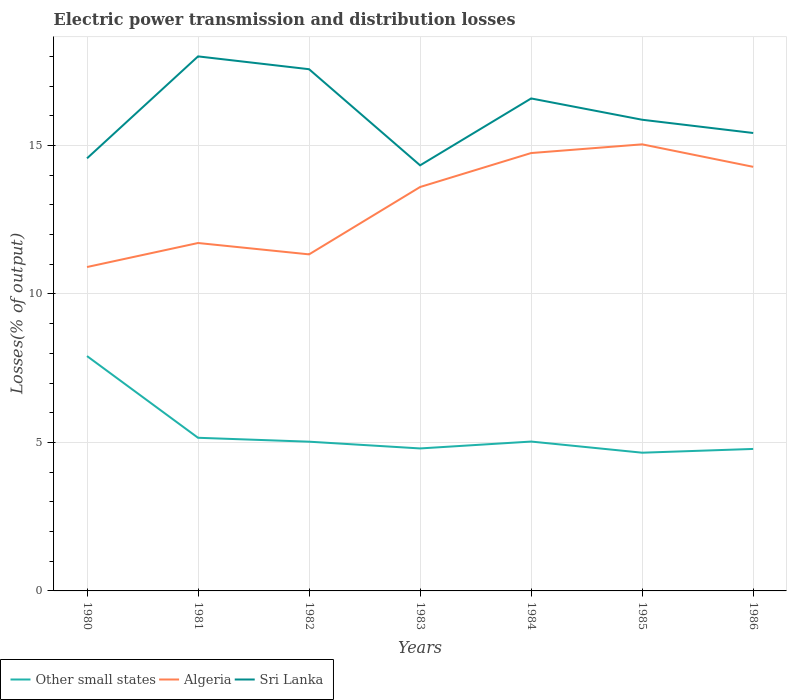How many different coloured lines are there?
Your answer should be compact. 3. Is the number of lines equal to the number of legend labels?
Your answer should be very brief. Yes. Across all years, what is the maximum electric power transmission and distribution losses in Other small states?
Ensure brevity in your answer.  4.66. In which year was the electric power transmission and distribution losses in Algeria maximum?
Keep it short and to the point. 1980. What is the total electric power transmission and distribution losses in Other small states in the graph?
Provide a short and direct response. 0.24. What is the difference between the highest and the second highest electric power transmission and distribution losses in Algeria?
Offer a terse response. 4.13. What is the difference between the highest and the lowest electric power transmission and distribution losses in Algeria?
Keep it short and to the point. 4. Is the electric power transmission and distribution losses in Sri Lanka strictly greater than the electric power transmission and distribution losses in Other small states over the years?
Provide a short and direct response. No. How many lines are there?
Give a very brief answer. 3. How many years are there in the graph?
Your response must be concise. 7. Are the values on the major ticks of Y-axis written in scientific E-notation?
Your answer should be compact. No. Does the graph contain any zero values?
Keep it short and to the point. No. Does the graph contain grids?
Ensure brevity in your answer.  Yes. How many legend labels are there?
Your answer should be very brief. 3. What is the title of the graph?
Your answer should be compact. Electric power transmission and distribution losses. Does "Marshall Islands" appear as one of the legend labels in the graph?
Your response must be concise. No. What is the label or title of the Y-axis?
Provide a succinct answer. Losses(% of output). What is the Losses(% of output) of Other small states in 1980?
Offer a very short reply. 7.91. What is the Losses(% of output) in Algeria in 1980?
Ensure brevity in your answer.  10.91. What is the Losses(% of output) in Sri Lanka in 1980?
Provide a succinct answer. 14.57. What is the Losses(% of output) of Other small states in 1981?
Keep it short and to the point. 5.16. What is the Losses(% of output) of Algeria in 1981?
Your answer should be very brief. 11.72. What is the Losses(% of output) in Sri Lanka in 1981?
Ensure brevity in your answer.  18. What is the Losses(% of output) of Other small states in 1982?
Ensure brevity in your answer.  5.03. What is the Losses(% of output) of Algeria in 1982?
Offer a very short reply. 11.33. What is the Losses(% of output) in Sri Lanka in 1982?
Provide a succinct answer. 17.57. What is the Losses(% of output) in Other small states in 1983?
Make the answer very short. 4.8. What is the Losses(% of output) in Algeria in 1983?
Offer a very short reply. 13.6. What is the Losses(% of output) in Sri Lanka in 1983?
Your response must be concise. 14.33. What is the Losses(% of output) in Other small states in 1984?
Keep it short and to the point. 5.03. What is the Losses(% of output) of Algeria in 1984?
Provide a succinct answer. 14.75. What is the Losses(% of output) of Sri Lanka in 1984?
Your response must be concise. 16.59. What is the Losses(% of output) of Other small states in 1985?
Make the answer very short. 4.66. What is the Losses(% of output) in Algeria in 1985?
Your response must be concise. 15.04. What is the Losses(% of output) of Sri Lanka in 1985?
Give a very brief answer. 15.87. What is the Losses(% of output) of Other small states in 1986?
Provide a short and direct response. 4.78. What is the Losses(% of output) of Algeria in 1986?
Keep it short and to the point. 14.28. What is the Losses(% of output) of Sri Lanka in 1986?
Give a very brief answer. 15.42. Across all years, what is the maximum Losses(% of output) of Other small states?
Offer a very short reply. 7.91. Across all years, what is the maximum Losses(% of output) of Algeria?
Offer a very short reply. 15.04. Across all years, what is the maximum Losses(% of output) of Sri Lanka?
Make the answer very short. 18. Across all years, what is the minimum Losses(% of output) in Other small states?
Offer a terse response. 4.66. Across all years, what is the minimum Losses(% of output) of Algeria?
Offer a very short reply. 10.91. Across all years, what is the minimum Losses(% of output) of Sri Lanka?
Ensure brevity in your answer.  14.33. What is the total Losses(% of output) in Other small states in the graph?
Keep it short and to the point. 37.36. What is the total Losses(% of output) of Algeria in the graph?
Your answer should be compact. 91.63. What is the total Losses(% of output) in Sri Lanka in the graph?
Your response must be concise. 112.35. What is the difference between the Losses(% of output) in Other small states in 1980 and that in 1981?
Keep it short and to the point. 2.75. What is the difference between the Losses(% of output) in Algeria in 1980 and that in 1981?
Provide a short and direct response. -0.81. What is the difference between the Losses(% of output) in Sri Lanka in 1980 and that in 1981?
Your answer should be very brief. -3.43. What is the difference between the Losses(% of output) in Other small states in 1980 and that in 1982?
Offer a very short reply. 2.88. What is the difference between the Losses(% of output) in Algeria in 1980 and that in 1982?
Your answer should be compact. -0.43. What is the difference between the Losses(% of output) in Sri Lanka in 1980 and that in 1982?
Provide a succinct answer. -3. What is the difference between the Losses(% of output) in Other small states in 1980 and that in 1983?
Keep it short and to the point. 3.11. What is the difference between the Losses(% of output) in Algeria in 1980 and that in 1983?
Ensure brevity in your answer.  -2.7. What is the difference between the Losses(% of output) of Sri Lanka in 1980 and that in 1983?
Ensure brevity in your answer.  0.24. What is the difference between the Losses(% of output) of Other small states in 1980 and that in 1984?
Your response must be concise. 2.88. What is the difference between the Losses(% of output) of Algeria in 1980 and that in 1984?
Your response must be concise. -3.84. What is the difference between the Losses(% of output) of Sri Lanka in 1980 and that in 1984?
Your answer should be very brief. -2.02. What is the difference between the Losses(% of output) of Other small states in 1980 and that in 1985?
Provide a short and direct response. 3.25. What is the difference between the Losses(% of output) of Algeria in 1980 and that in 1985?
Keep it short and to the point. -4.13. What is the difference between the Losses(% of output) of Sri Lanka in 1980 and that in 1985?
Your answer should be very brief. -1.3. What is the difference between the Losses(% of output) of Other small states in 1980 and that in 1986?
Offer a very short reply. 3.13. What is the difference between the Losses(% of output) in Algeria in 1980 and that in 1986?
Make the answer very short. -3.37. What is the difference between the Losses(% of output) of Sri Lanka in 1980 and that in 1986?
Ensure brevity in your answer.  -0.85. What is the difference between the Losses(% of output) of Other small states in 1981 and that in 1982?
Your response must be concise. 0.13. What is the difference between the Losses(% of output) in Algeria in 1981 and that in 1982?
Ensure brevity in your answer.  0.38. What is the difference between the Losses(% of output) of Sri Lanka in 1981 and that in 1982?
Your answer should be compact. 0.43. What is the difference between the Losses(% of output) of Other small states in 1981 and that in 1983?
Provide a short and direct response. 0.36. What is the difference between the Losses(% of output) of Algeria in 1981 and that in 1983?
Your answer should be very brief. -1.89. What is the difference between the Losses(% of output) of Sri Lanka in 1981 and that in 1983?
Your answer should be very brief. 3.67. What is the difference between the Losses(% of output) of Other small states in 1981 and that in 1984?
Offer a very short reply. 0.13. What is the difference between the Losses(% of output) of Algeria in 1981 and that in 1984?
Your response must be concise. -3.03. What is the difference between the Losses(% of output) of Sri Lanka in 1981 and that in 1984?
Offer a very short reply. 1.42. What is the difference between the Losses(% of output) in Other small states in 1981 and that in 1985?
Your response must be concise. 0.5. What is the difference between the Losses(% of output) of Algeria in 1981 and that in 1985?
Offer a terse response. -3.32. What is the difference between the Losses(% of output) of Sri Lanka in 1981 and that in 1985?
Provide a short and direct response. 2.13. What is the difference between the Losses(% of output) of Other small states in 1981 and that in 1986?
Your response must be concise. 0.38. What is the difference between the Losses(% of output) of Algeria in 1981 and that in 1986?
Provide a short and direct response. -2.57. What is the difference between the Losses(% of output) in Sri Lanka in 1981 and that in 1986?
Your response must be concise. 2.58. What is the difference between the Losses(% of output) of Other small states in 1982 and that in 1983?
Your answer should be compact. 0.23. What is the difference between the Losses(% of output) of Algeria in 1982 and that in 1983?
Your answer should be very brief. -2.27. What is the difference between the Losses(% of output) of Sri Lanka in 1982 and that in 1983?
Keep it short and to the point. 3.24. What is the difference between the Losses(% of output) of Other small states in 1982 and that in 1984?
Your answer should be very brief. -0. What is the difference between the Losses(% of output) in Algeria in 1982 and that in 1984?
Provide a short and direct response. -3.41. What is the difference between the Losses(% of output) in Sri Lanka in 1982 and that in 1984?
Your answer should be compact. 0.98. What is the difference between the Losses(% of output) in Other small states in 1982 and that in 1985?
Your answer should be compact. 0.37. What is the difference between the Losses(% of output) of Algeria in 1982 and that in 1985?
Offer a very short reply. -3.71. What is the difference between the Losses(% of output) of Sri Lanka in 1982 and that in 1985?
Your answer should be compact. 1.7. What is the difference between the Losses(% of output) in Other small states in 1982 and that in 1986?
Your answer should be very brief. 0.24. What is the difference between the Losses(% of output) in Algeria in 1982 and that in 1986?
Make the answer very short. -2.95. What is the difference between the Losses(% of output) of Sri Lanka in 1982 and that in 1986?
Provide a succinct answer. 2.15. What is the difference between the Losses(% of output) in Other small states in 1983 and that in 1984?
Offer a very short reply. -0.23. What is the difference between the Losses(% of output) in Algeria in 1983 and that in 1984?
Ensure brevity in your answer.  -1.14. What is the difference between the Losses(% of output) of Sri Lanka in 1983 and that in 1984?
Ensure brevity in your answer.  -2.25. What is the difference between the Losses(% of output) in Other small states in 1983 and that in 1985?
Give a very brief answer. 0.14. What is the difference between the Losses(% of output) in Algeria in 1983 and that in 1985?
Provide a succinct answer. -1.44. What is the difference between the Losses(% of output) of Sri Lanka in 1983 and that in 1985?
Make the answer very short. -1.54. What is the difference between the Losses(% of output) of Other small states in 1983 and that in 1986?
Give a very brief answer. 0.02. What is the difference between the Losses(% of output) in Algeria in 1983 and that in 1986?
Keep it short and to the point. -0.68. What is the difference between the Losses(% of output) in Sri Lanka in 1983 and that in 1986?
Offer a terse response. -1.09. What is the difference between the Losses(% of output) in Other small states in 1984 and that in 1985?
Keep it short and to the point. 0.38. What is the difference between the Losses(% of output) in Algeria in 1984 and that in 1985?
Your response must be concise. -0.29. What is the difference between the Losses(% of output) in Sri Lanka in 1984 and that in 1985?
Give a very brief answer. 0.72. What is the difference between the Losses(% of output) of Other small states in 1984 and that in 1986?
Your answer should be compact. 0.25. What is the difference between the Losses(% of output) of Algeria in 1984 and that in 1986?
Offer a terse response. 0.46. What is the difference between the Losses(% of output) in Sri Lanka in 1984 and that in 1986?
Provide a short and direct response. 1.16. What is the difference between the Losses(% of output) of Other small states in 1985 and that in 1986?
Make the answer very short. -0.13. What is the difference between the Losses(% of output) of Algeria in 1985 and that in 1986?
Your answer should be very brief. 0.76. What is the difference between the Losses(% of output) of Sri Lanka in 1985 and that in 1986?
Keep it short and to the point. 0.45. What is the difference between the Losses(% of output) in Other small states in 1980 and the Losses(% of output) in Algeria in 1981?
Offer a very short reply. -3.81. What is the difference between the Losses(% of output) in Other small states in 1980 and the Losses(% of output) in Sri Lanka in 1981?
Ensure brevity in your answer.  -10.09. What is the difference between the Losses(% of output) in Algeria in 1980 and the Losses(% of output) in Sri Lanka in 1981?
Your answer should be compact. -7.09. What is the difference between the Losses(% of output) of Other small states in 1980 and the Losses(% of output) of Algeria in 1982?
Ensure brevity in your answer.  -3.42. What is the difference between the Losses(% of output) in Other small states in 1980 and the Losses(% of output) in Sri Lanka in 1982?
Offer a very short reply. -9.66. What is the difference between the Losses(% of output) in Algeria in 1980 and the Losses(% of output) in Sri Lanka in 1982?
Your answer should be very brief. -6.66. What is the difference between the Losses(% of output) in Other small states in 1980 and the Losses(% of output) in Algeria in 1983?
Your answer should be very brief. -5.69. What is the difference between the Losses(% of output) of Other small states in 1980 and the Losses(% of output) of Sri Lanka in 1983?
Keep it short and to the point. -6.42. What is the difference between the Losses(% of output) in Algeria in 1980 and the Losses(% of output) in Sri Lanka in 1983?
Your response must be concise. -3.42. What is the difference between the Losses(% of output) of Other small states in 1980 and the Losses(% of output) of Algeria in 1984?
Your answer should be compact. -6.84. What is the difference between the Losses(% of output) of Other small states in 1980 and the Losses(% of output) of Sri Lanka in 1984?
Offer a terse response. -8.68. What is the difference between the Losses(% of output) of Algeria in 1980 and the Losses(% of output) of Sri Lanka in 1984?
Ensure brevity in your answer.  -5.68. What is the difference between the Losses(% of output) of Other small states in 1980 and the Losses(% of output) of Algeria in 1985?
Keep it short and to the point. -7.13. What is the difference between the Losses(% of output) of Other small states in 1980 and the Losses(% of output) of Sri Lanka in 1985?
Offer a very short reply. -7.96. What is the difference between the Losses(% of output) of Algeria in 1980 and the Losses(% of output) of Sri Lanka in 1985?
Offer a very short reply. -4.96. What is the difference between the Losses(% of output) in Other small states in 1980 and the Losses(% of output) in Algeria in 1986?
Your answer should be very brief. -6.37. What is the difference between the Losses(% of output) in Other small states in 1980 and the Losses(% of output) in Sri Lanka in 1986?
Your answer should be compact. -7.51. What is the difference between the Losses(% of output) in Algeria in 1980 and the Losses(% of output) in Sri Lanka in 1986?
Give a very brief answer. -4.51. What is the difference between the Losses(% of output) of Other small states in 1981 and the Losses(% of output) of Algeria in 1982?
Ensure brevity in your answer.  -6.18. What is the difference between the Losses(% of output) in Other small states in 1981 and the Losses(% of output) in Sri Lanka in 1982?
Give a very brief answer. -12.41. What is the difference between the Losses(% of output) of Algeria in 1981 and the Losses(% of output) of Sri Lanka in 1982?
Keep it short and to the point. -5.85. What is the difference between the Losses(% of output) of Other small states in 1981 and the Losses(% of output) of Algeria in 1983?
Offer a terse response. -8.45. What is the difference between the Losses(% of output) of Other small states in 1981 and the Losses(% of output) of Sri Lanka in 1983?
Offer a very short reply. -9.18. What is the difference between the Losses(% of output) of Algeria in 1981 and the Losses(% of output) of Sri Lanka in 1983?
Provide a short and direct response. -2.62. What is the difference between the Losses(% of output) of Other small states in 1981 and the Losses(% of output) of Algeria in 1984?
Your answer should be compact. -9.59. What is the difference between the Losses(% of output) of Other small states in 1981 and the Losses(% of output) of Sri Lanka in 1984?
Your answer should be compact. -11.43. What is the difference between the Losses(% of output) of Algeria in 1981 and the Losses(% of output) of Sri Lanka in 1984?
Offer a terse response. -4.87. What is the difference between the Losses(% of output) of Other small states in 1981 and the Losses(% of output) of Algeria in 1985?
Ensure brevity in your answer.  -9.88. What is the difference between the Losses(% of output) of Other small states in 1981 and the Losses(% of output) of Sri Lanka in 1985?
Provide a short and direct response. -10.71. What is the difference between the Losses(% of output) in Algeria in 1981 and the Losses(% of output) in Sri Lanka in 1985?
Your answer should be compact. -4.15. What is the difference between the Losses(% of output) of Other small states in 1981 and the Losses(% of output) of Algeria in 1986?
Offer a terse response. -9.12. What is the difference between the Losses(% of output) of Other small states in 1981 and the Losses(% of output) of Sri Lanka in 1986?
Offer a terse response. -10.26. What is the difference between the Losses(% of output) of Algeria in 1981 and the Losses(% of output) of Sri Lanka in 1986?
Offer a terse response. -3.71. What is the difference between the Losses(% of output) in Other small states in 1982 and the Losses(% of output) in Algeria in 1983?
Make the answer very short. -8.58. What is the difference between the Losses(% of output) in Other small states in 1982 and the Losses(% of output) in Sri Lanka in 1983?
Offer a terse response. -9.31. What is the difference between the Losses(% of output) in Algeria in 1982 and the Losses(% of output) in Sri Lanka in 1983?
Your response must be concise. -3. What is the difference between the Losses(% of output) of Other small states in 1982 and the Losses(% of output) of Algeria in 1984?
Your answer should be very brief. -9.72. What is the difference between the Losses(% of output) of Other small states in 1982 and the Losses(% of output) of Sri Lanka in 1984?
Provide a short and direct response. -11.56. What is the difference between the Losses(% of output) in Algeria in 1982 and the Losses(% of output) in Sri Lanka in 1984?
Offer a very short reply. -5.25. What is the difference between the Losses(% of output) in Other small states in 1982 and the Losses(% of output) in Algeria in 1985?
Offer a terse response. -10.01. What is the difference between the Losses(% of output) in Other small states in 1982 and the Losses(% of output) in Sri Lanka in 1985?
Provide a short and direct response. -10.84. What is the difference between the Losses(% of output) of Algeria in 1982 and the Losses(% of output) of Sri Lanka in 1985?
Offer a terse response. -4.53. What is the difference between the Losses(% of output) of Other small states in 1982 and the Losses(% of output) of Algeria in 1986?
Give a very brief answer. -9.26. What is the difference between the Losses(% of output) of Other small states in 1982 and the Losses(% of output) of Sri Lanka in 1986?
Ensure brevity in your answer.  -10.4. What is the difference between the Losses(% of output) of Algeria in 1982 and the Losses(% of output) of Sri Lanka in 1986?
Offer a very short reply. -4.09. What is the difference between the Losses(% of output) of Other small states in 1983 and the Losses(% of output) of Algeria in 1984?
Offer a very short reply. -9.95. What is the difference between the Losses(% of output) in Other small states in 1983 and the Losses(% of output) in Sri Lanka in 1984?
Provide a succinct answer. -11.79. What is the difference between the Losses(% of output) in Algeria in 1983 and the Losses(% of output) in Sri Lanka in 1984?
Offer a very short reply. -2.98. What is the difference between the Losses(% of output) of Other small states in 1983 and the Losses(% of output) of Algeria in 1985?
Your answer should be compact. -10.24. What is the difference between the Losses(% of output) of Other small states in 1983 and the Losses(% of output) of Sri Lanka in 1985?
Provide a succinct answer. -11.07. What is the difference between the Losses(% of output) in Algeria in 1983 and the Losses(% of output) in Sri Lanka in 1985?
Keep it short and to the point. -2.27. What is the difference between the Losses(% of output) in Other small states in 1983 and the Losses(% of output) in Algeria in 1986?
Your answer should be very brief. -9.48. What is the difference between the Losses(% of output) in Other small states in 1983 and the Losses(% of output) in Sri Lanka in 1986?
Make the answer very short. -10.62. What is the difference between the Losses(% of output) in Algeria in 1983 and the Losses(% of output) in Sri Lanka in 1986?
Give a very brief answer. -1.82. What is the difference between the Losses(% of output) of Other small states in 1984 and the Losses(% of output) of Algeria in 1985?
Provide a succinct answer. -10.01. What is the difference between the Losses(% of output) of Other small states in 1984 and the Losses(% of output) of Sri Lanka in 1985?
Ensure brevity in your answer.  -10.84. What is the difference between the Losses(% of output) of Algeria in 1984 and the Losses(% of output) of Sri Lanka in 1985?
Provide a succinct answer. -1.12. What is the difference between the Losses(% of output) in Other small states in 1984 and the Losses(% of output) in Algeria in 1986?
Make the answer very short. -9.25. What is the difference between the Losses(% of output) of Other small states in 1984 and the Losses(% of output) of Sri Lanka in 1986?
Provide a short and direct response. -10.39. What is the difference between the Losses(% of output) in Algeria in 1984 and the Losses(% of output) in Sri Lanka in 1986?
Make the answer very short. -0.68. What is the difference between the Losses(% of output) in Other small states in 1985 and the Losses(% of output) in Algeria in 1986?
Your answer should be compact. -9.63. What is the difference between the Losses(% of output) in Other small states in 1985 and the Losses(% of output) in Sri Lanka in 1986?
Provide a succinct answer. -10.77. What is the difference between the Losses(% of output) in Algeria in 1985 and the Losses(% of output) in Sri Lanka in 1986?
Your answer should be very brief. -0.38. What is the average Losses(% of output) in Other small states per year?
Give a very brief answer. 5.34. What is the average Losses(% of output) in Algeria per year?
Make the answer very short. 13.09. What is the average Losses(% of output) of Sri Lanka per year?
Your answer should be very brief. 16.05. In the year 1980, what is the difference between the Losses(% of output) of Other small states and Losses(% of output) of Algeria?
Your response must be concise. -3. In the year 1980, what is the difference between the Losses(% of output) in Other small states and Losses(% of output) in Sri Lanka?
Provide a short and direct response. -6.66. In the year 1980, what is the difference between the Losses(% of output) in Algeria and Losses(% of output) in Sri Lanka?
Give a very brief answer. -3.66. In the year 1981, what is the difference between the Losses(% of output) of Other small states and Losses(% of output) of Algeria?
Keep it short and to the point. -6.56. In the year 1981, what is the difference between the Losses(% of output) in Other small states and Losses(% of output) in Sri Lanka?
Keep it short and to the point. -12.84. In the year 1981, what is the difference between the Losses(% of output) of Algeria and Losses(% of output) of Sri Lanka?
Keep it short and to the point. -6.29. In the year 1982, what is the difference between the Losses(% of output) in Other small states and Losses(% of output) in Algeria?
Offer a very short reply. -6.31. In the year 1982, what is the difference between the Losses(% of output) in Other small states and Losses(% of output) in Sri Lanka?
Give a very brief answer. -12.54. In the year 1982, what is the difference between the Losses(% of output) in Algeria and Losses(% of output) in Sri Lanka?
Give a very brief answer. -6.24. In the year 1983, what is the difference between the Losses(% of output) in Other small states and Losses(% of output) in Algeria?
Offer a terse response. -8.8. In the year 1983, what is the difference between the Losses(% of output) in Other small states and Losses(% of output) in Sri Lanka?
Make the answer very short. -9.53. In the year 1983, what is the difference between the Losses(% of output) in Algeria and Losses(% of output) in Sri Lanka?
Make the answer very short. -0.73. In the year 1984, what is the difference between the Losses(% of output) of Other small states and Losses(% of output) of Algeria?
Your answer should be very brief. -9.72. In the year 1984, what is the difference between the Losses(% of output) of Other small states and Losses(% of output) of Sri Lanka?
Provide a short and direct response. -11.56. In the year 1984, what is the difference between the Losses(% of output) of Algeria and Losses(% of output) of Sri Lanka?
Your answer should be very brief. -1.84. In the year 1985, what is the difference between the Losses(% of output) of Other small states and Losses(% of output) of Algeria?
Ensure brevity in your answer.  -10.38. In the year 1985, what is the difference between the Losses(% of output) in Other small states and Losses(% of output) in Sri Lanka?
Offer a very short reply. -11.21. In the year 1985, what is the difference between the Losses(% of output) in Algeria and Losses(% of output) in Sri Lanka?
Offer a terse response. -0.83. In the year 1986, what is the difference between the Losses(% of output) in Other small states and Losses(% of output) in Algeria?
Your response must be concise. -9.5. In the year 1986, what is the difference between the Losses(% of output) of Other small states and Losses(% of output) of Sri Lanka?
Ensure brevity in your answer.  -10.64. In the year 1986, what is the difference between the Losses(% of output) of Algeria and Losses(% of output) of Sri Lanka?
Offer a very short reply. -1.14. What is the ratio of the Losses(% of output) of Other small states in 1980 to that in 1981?
Give a very brief answer. 1.53. What is the ratio of the Losses(% of output) of Sri Lanka in 1980 to that in 1981?
Provide a short and direct response. 0.81. What is the ratio of the Losses(% of output) of Other small states in 1980 to that in 1982?
Keep it short and to the point. 1.57. What is the ratio of the Losses(% of output) in Algeria in 1980 to that in 1982?
Provide a succinct answer. 0.96. What is the ratio of the Losses(% of output) of Sri Lanka in 1980 to that in 1982?
Your answer should be compact. 0.83. What is the ratio of the Losses(% of output) of Other small states in 1980 to that in 1983?
Your response must be concise. 1.65. What is the ratio of the Losses(% of output) of Algeria in 1980 to that in 1983?
Ensure brevity in your answer.  0.8. What is the ratio of the Losses(% of output) of Sri Lanka in 1980 to that in 1983?
Keep it short and to the point. 1.02. What is the ratio of the Losses(% of output) of Other small states in 1980 to that in 1984?
Keep it short and to the point. 1.57. What is the ratio of the Losses(% of output) in Algeria in 1980 to that in 1984?
Your answer should be very brief. 0.74. What is the ratio of the Losses(% of output) of Sri Lanka in 1980 to that in 1984?
Your response must be concise. 0.88. What is the ratio of the Losses(% of output) in Other small states in 1980 to that in 1985?
Make the answer very short. 1.7. What is the ratio of the Losses(% of output) in Algeria in 1980 to that in 1985?
Your answer should be very brief. 0.73. What is the ratio of the Losses(% of output) in Sri Lanka in 1980 to that in 1985?
Offer a terse response. 0.92. What is the ratio of the Losses(% of output) of Other small states in 1980 to that in 1986?
Keep it short and to the point. 1.65. What is the ratio of the Losses(% of output) of Algeria in 1980 to that in 1986?
Ensure brevity in your answer.  0.76. What is the ratio of the Losses(% of output) of Sri Lanka in 1980 to that in 1986?
Provide a succinct answer. 0.94. What is the ratio of the Losses(% of output) in Other small states in 1981 to that in 1982?
Offer a terse response. 1.03. What is the ratio of the Losses(% of output) of Algeria in 1981 to that in 1982?
Your answer should be very brief. 1.03. What is the ratio of the Losses(% of output) in Sri Lanka in 1981 to that in 1982?
Give a very brief answer. 1.02. What is the ratio of the Losses(% of output) in Other small states in 1981 to that in 1983?
Your response must be concise. 1.07. What is the ratio of the Losses(% of output) in Algeria in 1981 to that in 1983?
Provide a succinct answer. 0.86. What is the ratio of the Losses(% of output) of Sri Lanka in 1981 to that in 1983?
Your answer should be very brief. 1.26. What is the ratio of the Losses(% of output) of Other small states in 1981 to that in 1984?
Provide a succinct answer. 1.03. What is the ratio of the Losses(% of output) in Algeria in 1981 to that in 1984?
Provide a succinct answer. 0.79. What is the ratio of the Losses(% of output) in Sri Lanka in 1981 to that in 1984?
Make the answer very short. 1.09. What is the ratio of the Losses(% of output) of Other small states in 1981 to that in 1985?
Provide a short and direct response. 1.11. What is the ratio of the Losses(% of output) in Algeria in 1981 to that in 1985?
Offer a very short reply. 0.78. What is the ratio of the Losses(% of output) of Sri Lanka in 1981 to that in 1985?
Ensure brevity in your answer.  1.13. What is the ratio of the Losses(% of output) in Other small states in 1981 to that in 1986?
Provide a succinct answer. 1.08. What is the ratio of the Losses(% of output) in Algeria in 1981 to that in 1986?
Your answer should be very brief. 0.82. What is the ratio of the Losses(% of output) in Sri Lanka in 1981 to that in 1986?
Make the answer very short. 1.17. What is the ratio of the Losses(% of output) in Other small states in 1982 to that in 1983?
Keep it short and to the point. 1.05. What is the ratio of the Losses(% of output) in Algeria in 1982 to that in 1983?
Give a very brief answer. 0.83. What is the ratio of the Losses(% of output) of Sri Lanka in 1982 to that in 1983?
Your answer should be very brief. 1.23. What is the ratio of the Losses(% of output) in Other small states in 1982 to that in 1984?
Offer a very short reply. 1. What is the ratio of the Losses(% of output) in Algeria in 1982 to that in 1984?
Your answer should be very brief. 0.77. What is the ratio of the Losses(% of output) of Sri Lanka in 1982 to that in 1984?
Your answer should be compact. 1.06. What is the ratio of the Losses(% of output) of Other small states in 1982 to that in 1985?
Provide a short and direct response. 1.08. What is the ratio of the Losses(% of output) in Algeria in 1982 to that in 1985?
Provide a succinct answer. 0.75. What is the ratio of the Losses(% of output) in Sri Lanka in 1982 to that in 1985?
Your response must be concise. 1.11. What is the ratio of the Losses(% of output) of Other small states in 1982 to that in 1986?
Your answer should be compact. 1.05. What is the ratio of the Losses(% of output) in Algeria in 1982 to that in 1986?
Your answer should be compact. 0.79. What is the ratio of the Losses(% of output) in Sri Lanka in 1982 to that in 1986?
Your answer should be compact. 1.14. What is the ratio of the Losses(% of output) in Other small states in 1983 to that in 1984?
Keep it short and to the point. 0.95. What is the ratio of the Losses(% of output) of Algeria in 1983 to that in 1984?
Give a very brief answer. 0.92. What is the ratio of the Losses(% of output) of Sri Lanka in 1983 to that in 1984?
Offer a terse response. 0.86. What is the ratio of the Losses(% of output) of Other small states in 1983 to that in 1985?
Your answer should be compact. 1.03. What is the ratio of the Losses(% of output) in Algeria in 1983 to that in 1985?
Keep it short and to the point. 0.9. What is the ratio of the Losses(% of output) of Sri Lanka in 1983 to that in 1985?
Ensure brevity in your answer.  0.9. What is the ratio of the Losses(% of output) of Other small states in 1983 to that in 1986?
Provide a succinct answer. 1. What is the ratio of the Losses(% of output) in Algeria in 1983 to that in 1986?
Make the answer very short. 0.95. What is the ratio of the Losses(% of output) in Sri Lanka in 1983 to that in 1986?
Ensure brevity in your answer.  0.93. What is the ratio of the Losses(% of output) in Other small states in 1984 to that in 1985?
Offer a terse response. 1.08. What is the ratio of the Losses(% of output) in Algeria in 1984 to that in 1985?
Make the answer very short. 0.98. What is the ratio of the Losses(% of output) of Sri Lanka in 1984 to that in 1985?
Offer a terse response. 1.05. What is the ratio of the Losses(% of output) of Other small states in 1984 to that in 1986?
Offer a very short reply. 1.05. What is the ratio of the Losses(% of output) of Algeria in 1984 to that in 1986?
Your answer should be very brief. 1.03. What is the ratio of the Losses(% of output) in Sri Lanka in 1984 to that in 1986?
Your answer should be very brief. 1.08. What is the ratio of the Losses(% of output) in Other small states in 1985 to that in 1986?
Provide a succinct answer. 0.97. What is the ratio of the Losses(% of output) of Algeria in 1985 to that in 1986?
Offer a very short reply. 1.05. What is the ratio of the Losses(% of output) of Sri Lanka in 1985 to that in 1986?
Offer a very short reply. 1.03. What is the difference between the highest and the second highest Losses(% of output) of Other small states?
Offer a very short reply. 2.75. What is the difference between the highest and the second highest Losses(% of output) of Algeria?
Make the answer very short. 0.29. What is the difference between the highest and the second highest Losses(% of output) of Sri Lanka?
Make the answer very short. 0.43. What is the difference between the highest and the lowest Losses(% of output) in Other small states?
Make the answer very short. 3.25. What is the difference between the highest and the lowest Losses(% of output) in Algeria?
Provide a short and direct response. 4.13. What is the difference between the highest and the lowest Losses(% of output) of Sri Lanka?
Your answer should be compact. 3.67. 